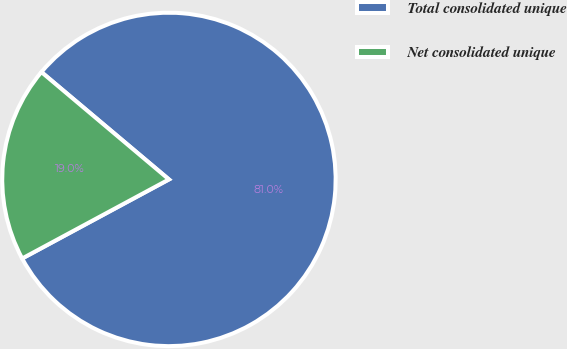<chart> <loc_0><loc_0><loc_500><loc_500><pie_chart><fcel>Total consolidated unique<fcel>Net consolidated unique<nl><fcel>81.0%<fcel>19.0%<nl></chart> 